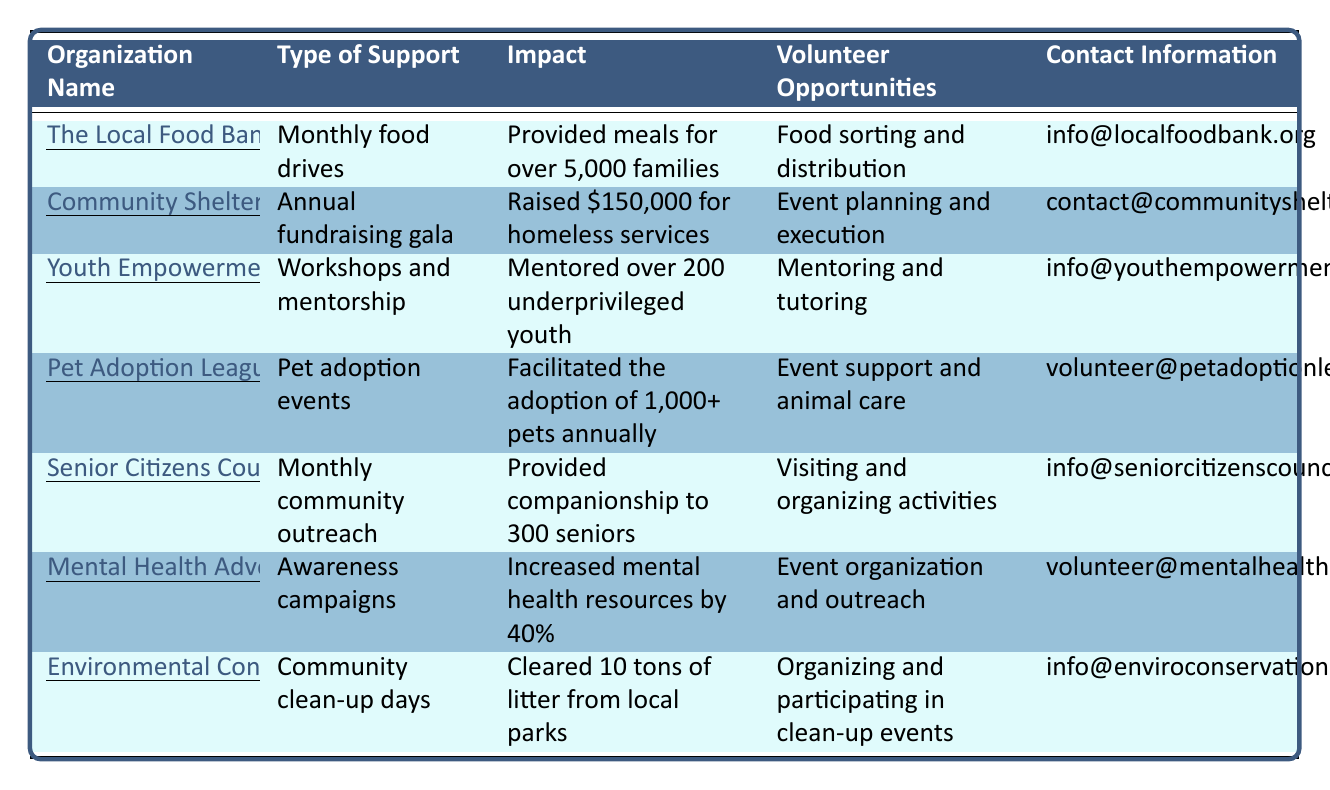What organization provides meals for more than 5,000 families? The Local Food Bank is listed as providing meals for over 5,000 families under the "Impact" column.
Answer: The Local Food Bank How many pets does the Pet Adoption League facilitate the adoption of annually? In the "Impact" column for the Pet Adoption League, it states they facilitate the adoption of 1,000+ pets annually.
Answer: 1,000+ Which organization raised $150,000 for homeless services? The "Community Shelter Network" is specifically mentioned in the "Impact" column as having raised $150,000 for homeless services.
Answer: Community Shelter Network Are the Senior Citizens Council involved in any community outreach activities? Yes, the "Type of Support" for the Senior Citizens Council indicates they conduct monthly community outreach, confirming their involvement in such activities.
Answer: Yes What is the main type of support provided by the Mental Health Advocacy Group? The "Type of Support" for the Mental Health Advocacy Group shows that they engage in awareness campaigns, which is their main focus.
Answer: Awareness campaigns How many underprivileged youth has the Youth Empowerment Program mentored? The impact statement in the table indicates that the Youth Empowerment Program has mentored over 200 underprivileged youth.
Answer: 200+ What volunteer opportunities are available for those interested in supporting the Environmental Conservation Network? The "Volunteer Opportunities" column indicates that individuals can organize and participate in clean-up events to support the Environmental Conservation Network.
Answer: Organizing and participating in clean-up events What is the total impact number of individuals positively affected by both the Local Food Bank and the Senior Citizens Council? The Local Food Bank has impacted over 5,000 families, and the Senior Citizens Council has provided companionship to 300 seniors, totaling 5,300 individuals affected (5,000 + 300).
Answer: 5,300 Which organization has the highest reported impact based on the information in the table? To determine this, we compare the impact values: The Local Food Bank (5,000 families), Community Shelter Network ($150,000), Youth Empowerment Program (200 youth), Pet Adoption League (1,000+ pets), Senior Citizens Council (300 seniors), Mental Health Advocacy Group (40% increase), and Environmental Conservation Network (10 tons of litter). The Community Shelter Network's raised funds show the highest impact.
Answer: Community Shelter Network Which organization requires volunteering in event planning and execution? The Community Shelter Network lists volunteering opportunities specifically in event planning and execution, as per the "Volunteer Opportunities" column.
Answer: Community Shelter Network 